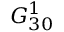<formula> <loc_0><loc_0><loc_500><loc_500>G _ { 3 0 } ^ { 1 }</formula> 